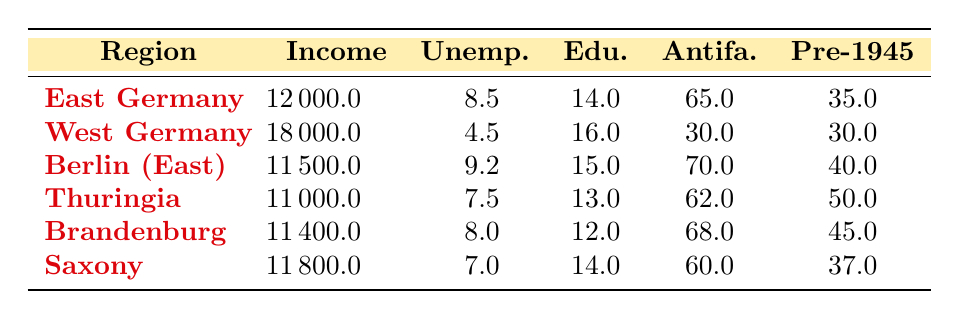What is the average income in East Germany? The table lists the average income for East Germany as 12000.0.
Answer: 12000.0 Which region has the highest participation rate in the antifascist movement? Berlin (East) has the participation rate of 70.0, which is higher than that of all other regions listed.
Answer: Berlin (East) Is the unemployment rate in West Germany lower than that in East Germany? The unemployment rate in West Germany is 4.5, while in East Germany it is 8.5, so West Germany has a lower unemployment rate.
Answer: Yes What is the average education level of regions in East Germany? The education levels for East Germany regions are 14.0 in East Germany, 15.0 in Berlin (East), 13.0 in Thuringia, 12.0 in Brandenburg, and 14.0 in Saxony. The average is calculated as (14 + 15 + 13 + 12 + 14)/5 = 13.6.
Answer: 13.6 How does the participation rate compare across Thuringia and Brandenburg? Thuringia has a participation rate of 62.0 while Brandenburg has a rate of 68.0. Therefore, Brandenburg has a higher participation rate than Thuringia.
Answer: Brandenburg has a higher participation rate What is the range of the average income from the table? The average incomes are 11000 in Thuringia and 18000 in West Germany. To find the range, we calculate 18000 - 11000 = 7000.
Answer: 7000 Is the percentage of the population born before 1945 in Saxony higher than in West Germany? Saxony's percentage is 37.0 while West Germany's is 30.0, indicating that Saxony has a higher percentage of the population born before 1945.
Answer: Yes If we consider only East German regions, what is the average participation rate in the antifascist movement? The participation rates for East German regions are 65.0 (East Germany), 70.0 (Berlin), 62.0 (Thuringia), 68.0 (Brandenburg), and 60.0 (Saxony). The average is (65 + 70 + 62 + 68 + 60) / 5 = 65.
Answer: 65 Which region has the lowest education level? Looking at the education levels in the table, Brandenburg has the lowest at 12.0.
Answer: Brandenburg 